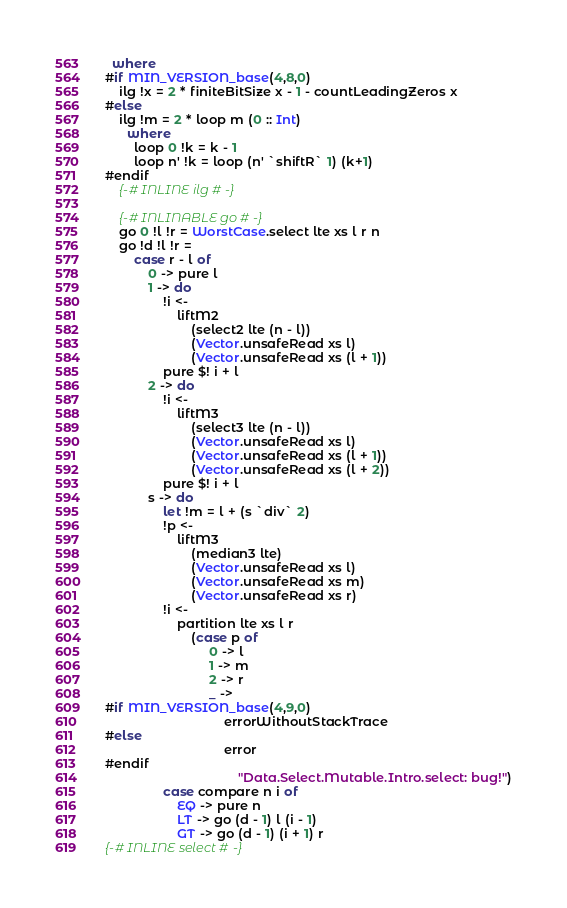<code> <loc_0><loc_0><loc_500><loc_500><_Haskell_>  where
#if MIN_VERSION_base(4,8,0)
    ilg !x = 2 * finiteBitSize x - 1 - countLeadingZeros x
#else
    ilg !m = 2 * loop m (0 :: Int)
      where
        loop 0 !k = k - 1
        loop n' !k = loop (n' `shiftR` 1) (k+1)
#endif
    {-# INLINE ilg #-}

    {-# INLINABLE go #-}
    go 0 !l !r = WorstCase.select lte xs l r n
    go !d !l !r =
        case r - l of
            0 -> pure l
            1 -> do
                !i <-
                    liftM2
                        (select2 lte (n - l))
                        (Vector.unsafeRead xs l)
                        (Vector.unsafeRead xs (l + 1))
                pure $! i + l
            2 -> do
                !i <-
                    liftM3
                        (select3 lte (n - l))
                        (Vector.unsafeRead xs l)
                        (Vector.unsafeRead xs (l + 1))
                        (Vector.unsafeRead xs (l + 2))
                pure $! i + l
            s -> do
                let !m = l + (s `div` 2)
                !p <-
                    liftM3
                        (median3 lte)
                        (Vector.unsafeRead xs l)
                        (Vector.unsafeRead xs m)
                        (Vector.unsafeRead xs r)
                !i <-
                    partition lte xs l r
                        (case p of
                             0 -> l
                             1 -> m
                             2 -> r
                             _ ->
#if MIN_VERSION_base(4,9,0)
                                 errorWithoutStackTrace
#else
                                 error
#endif
                                     "Data.Select.Mutable.Intro.select: bug!")
                case compare n i of
                    EQ -> pure n
                    LT -> go (d - 1) l (i - 1)
                    GT -> go (d - 1) (i + 1) r
{-# INLINE select #-}
</code> 